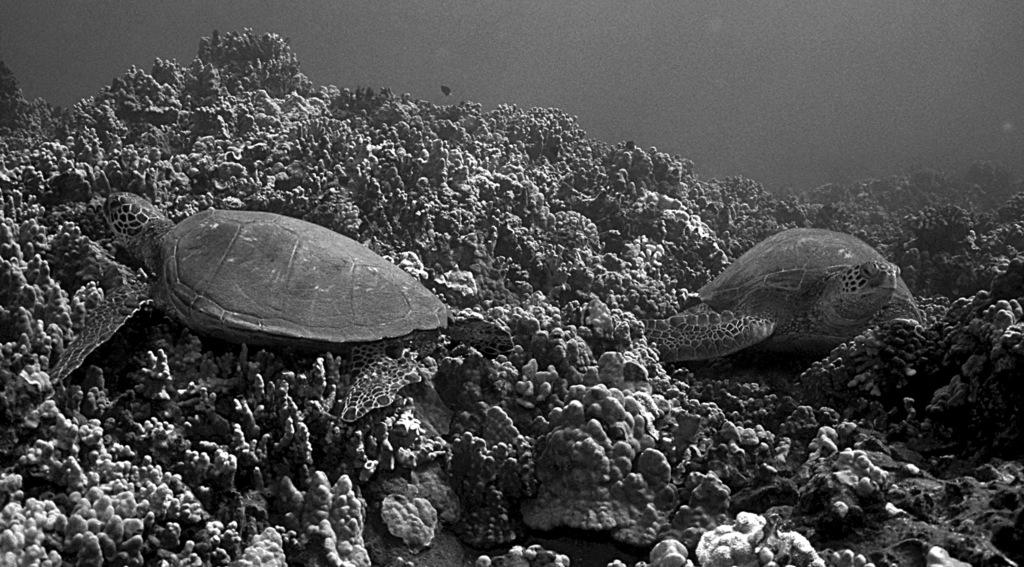What is the color scheme of the image? The image is black and white. What type of animals can be seen in the image? There are turtles in thes in the image. What natural formation is visible in the image? There are coral reefs in the image. What type of lock is used to secure the turtles in the image? There is no lock present in the image, as the turtles are not secured or confined in any way. 